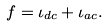<formula> <loc_0><loc_0><loc_500><loc_500>f = \iota _ { d c } + \iota _ { a c } .</formula> 